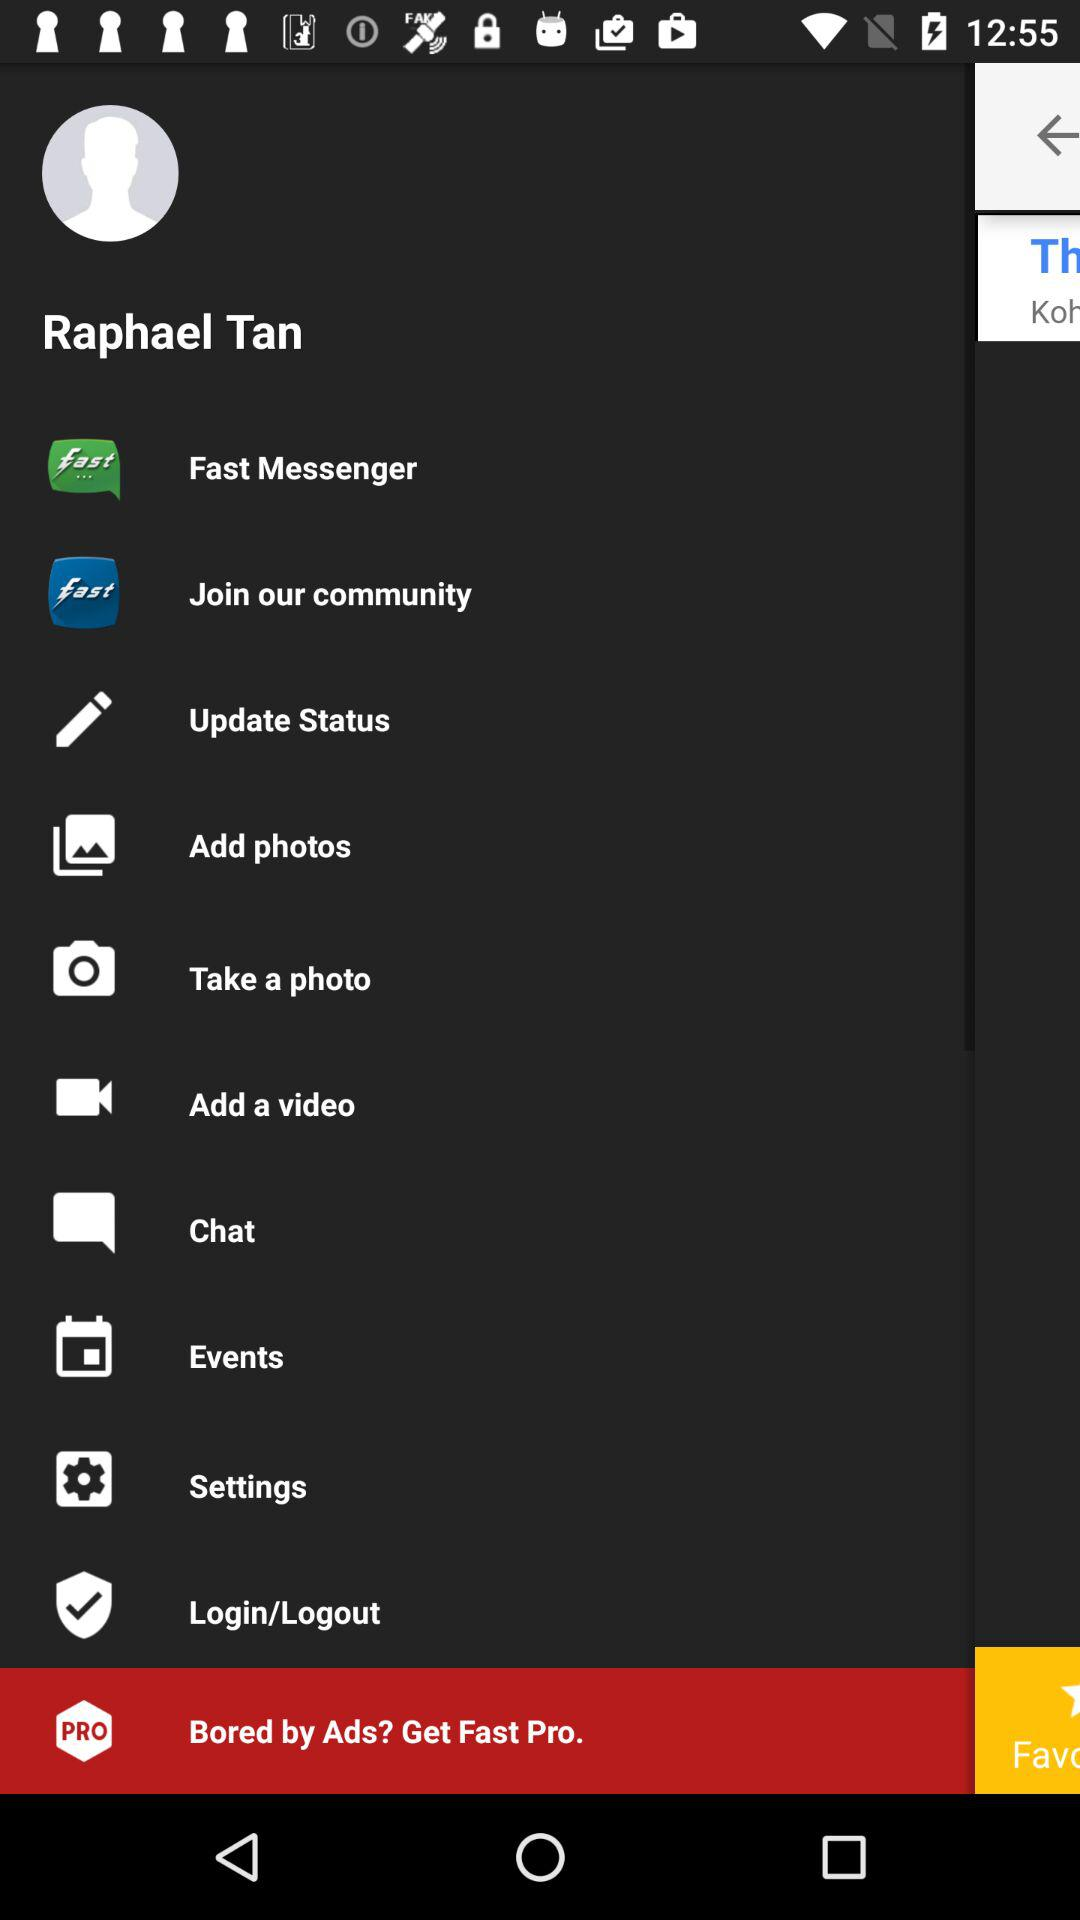What is the name of the user? The name of the user is Raphael Tan. 